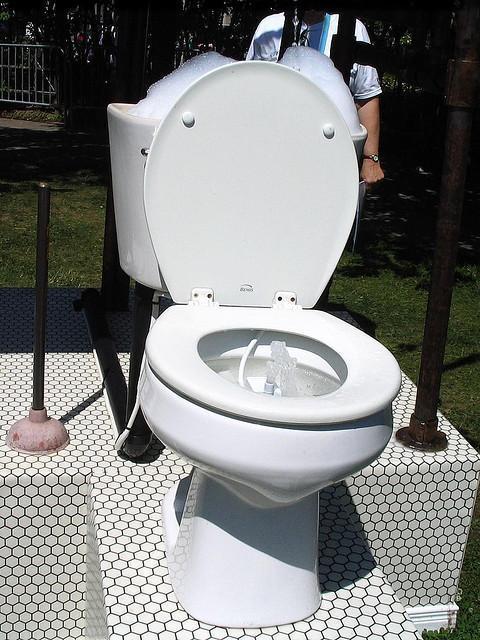How many people do you see?
Give a very brief answer. 1. 